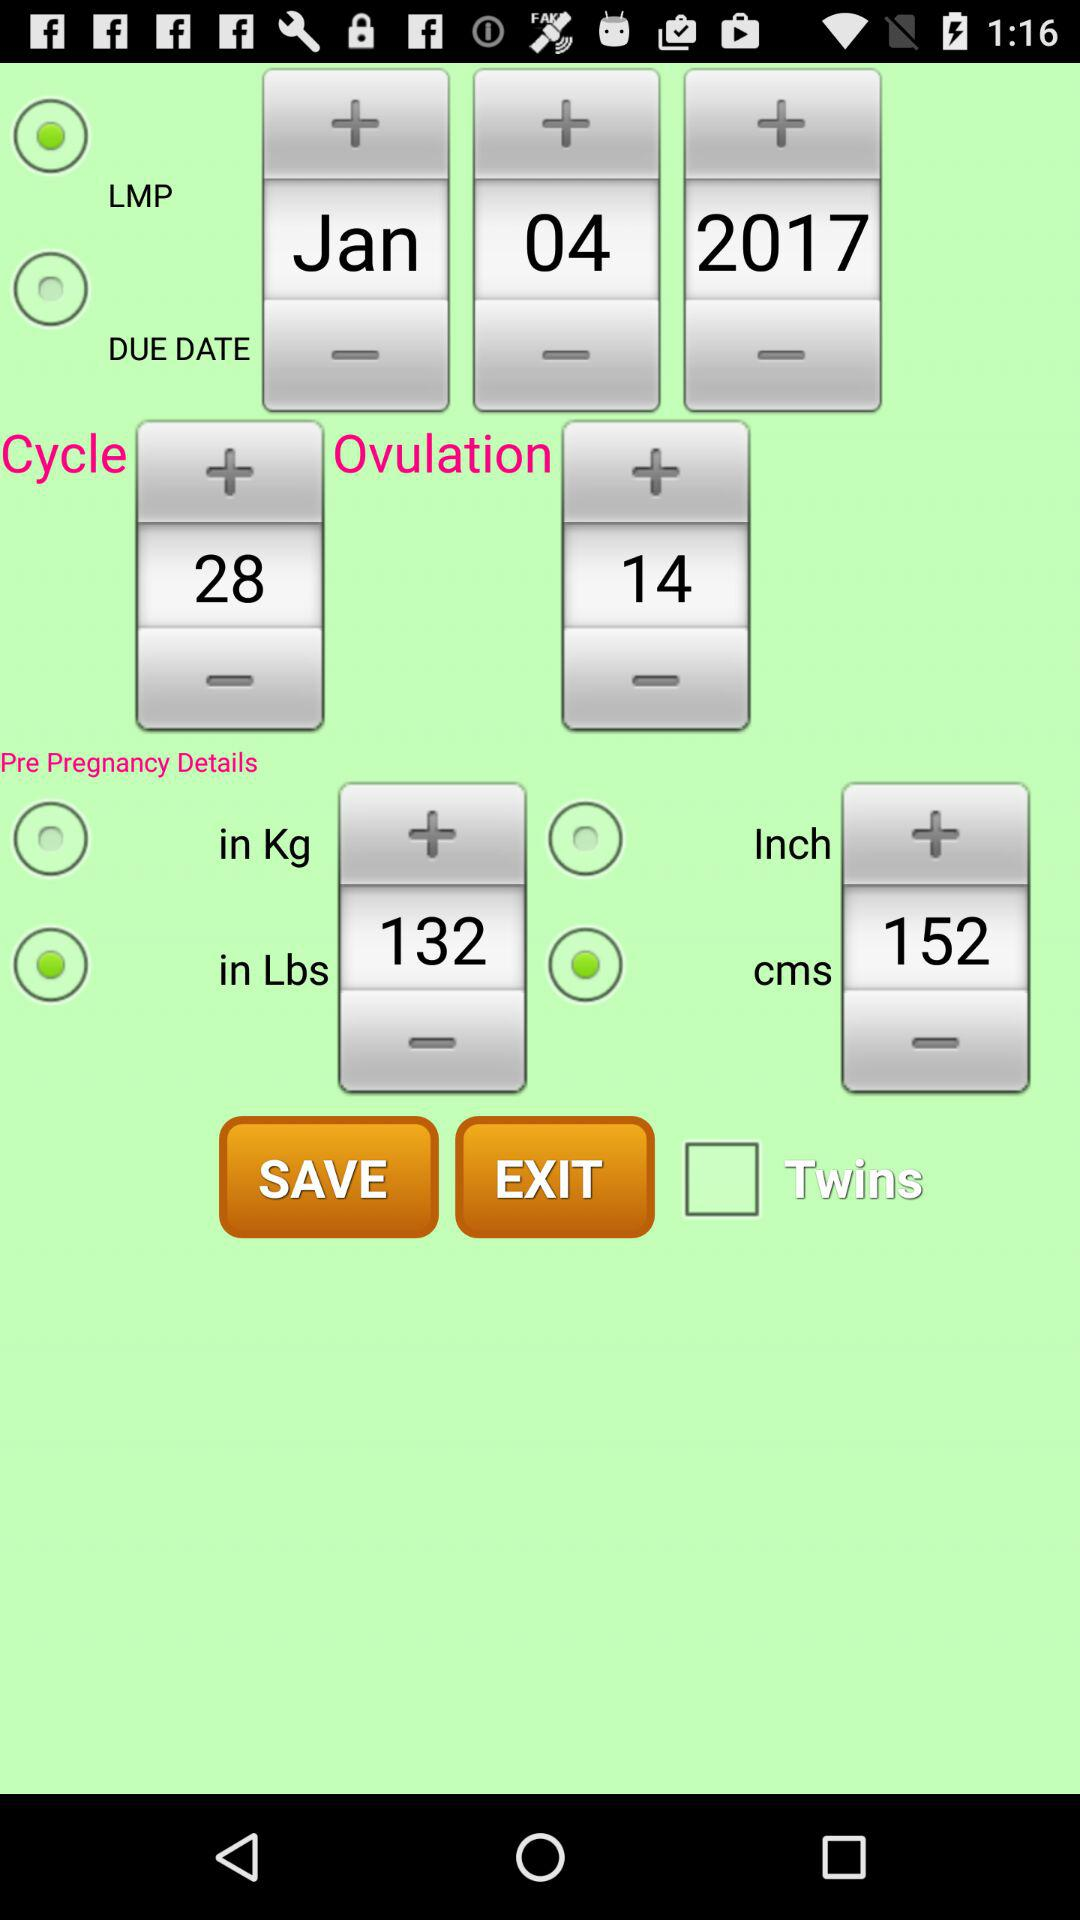Which date is shown? The shown date is January 4, 2017. 